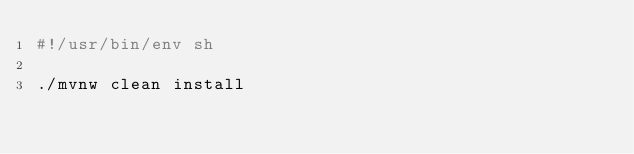Convert code to text. <code><loc_0><loc_0><loc_500><loc_500><_Bash_>#!/usr/bin/env sh

./mvnw clean install
</code> 